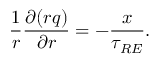Convert formula to latex. <formula><loc_0><loc_0><loc_500><loc_500>\frac { 1 } { r } \frac { \partial ( r q ) } { \partial r } = - \frac { x } { \tau _ { R E } } .</formula> 